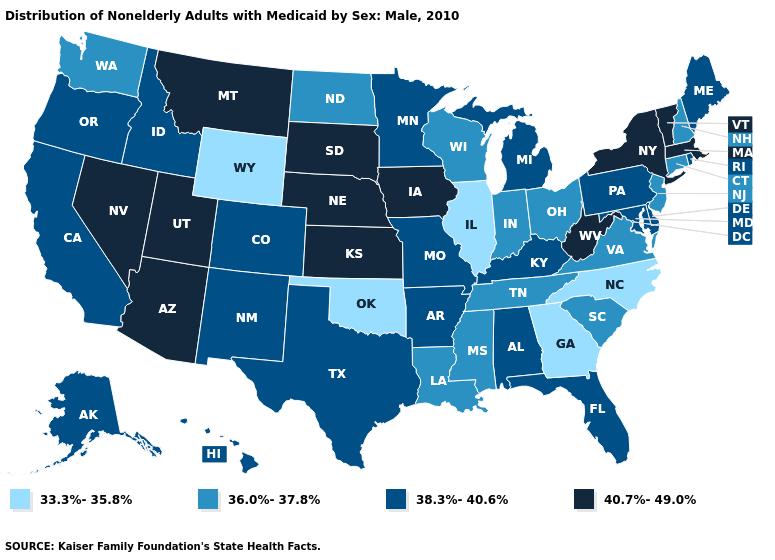Name the states that have a value in the range 40.7%-49.0%?
Be succinct. Arizona, Iowa, Kansas, Massachusetts, Montana, Nebraska, Nevada, New York, South Dakota, Utah, Vermont, West Virginia. Does New Jersey have a higher value than Arizona?
Keep it brief. No. Name the states that have a value in the range 40.7%-49.0%?
Give a very brief answer. Arizona, Iowa, Kansas, Massachusetts, Montana, Nebraska, Nevada, New York, South Dakota, Utah, Vermont, West Virginia. What is the lowest value in the USA?
Write a very short answer. 33.3%-35.8%. Among the states that border Massachusetts , does Connecticut have the lowest value?
Write a very short answer. Yes. Which states hav the highest value in the MidWest?
Be succinct. Iowa, Kansas, Nebraska, South Dakota. Among the states that border Colorado , does Utah have the lowest value?
Give a very brief answer. No. Name the states that have a value in the range 36.0%-37.8%?
Quick response, please. Connecticut, Indiana, Louisiana, Mississippi, New Hampshire, New Jersey, North Dakota, Ohio, South Carolina, Tennessee, Virginia, Washington, Wisconsin. Does Arizona have the highest value in the USA?
Keep it brief. Yes. Name the states that have a value in the range 33.3%-35.8%?
Answer briefly. Georgia, Illinois, North Carolina, Oklahoma, Wyoming. What is the highest value in the West ?
Quick response, please. 40.7%-49.0%. What is the highest value in the USA?
Keep it brief. 40.7%-49.0%. Does Louisiana have a higher value than North Carolina?
Write a very short answer. Yes. What is the lowest value in the MidWest?
Concise answer only. 33.3%-35.8%. What is the highest value in the West ?
Answer briefly. 40.7%-49.0%. 